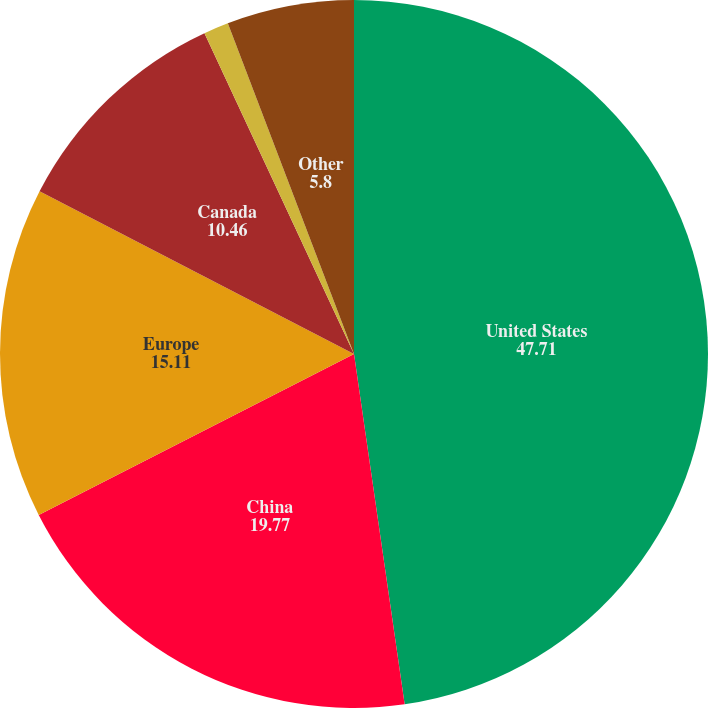Convert chart to OTSL. <chart><loc_0><loc_0><loc_500><loc_500><pie_chart><fcel>United States<fcel>China<fcel>Europe<fcel>Canada<fcel>Mexico<fcel>Other<nl><fcel>47.71%<fcel>19.77%<fcel>15.11%<fcel>10.46%<fcel>1.14%<fcel>5.8%<nl></chart> 